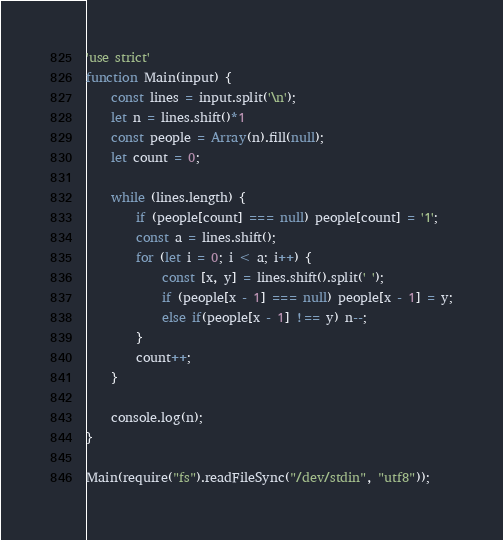<code> <loc_0><loc_0><loc_500><loc_500><_TypeScript_>'use strict'
function Main(input) {
	const lines = input.split('\n');
	let n = lines.shift()*1
	const people = Array(n).fill(null);
	let count = 0;

	while (lines.length) {
		if (people[count] === null) people[count] = '1';
		const a = lines.shift();
		for (let i = 0; i < a; i++) {
			const [x, y] = lines.shift().split(' ');
			if (people[x - 1] === null) people[x - 1] = y;
			else if(people[x - 1] !== y) n--;
		}
		count++;
	}
	
	console.log(n);
}

Main(require("fs").readFileSync("/dev/stdin", "utf8"));</code> 